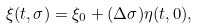<formula> <loc_0><loc_0><loc_500><loc_500>\xi ( t , \sigma ) = \xi _ { 0 } + ( \Delta \sigma ) \eta ( t , 0 ) ,</formula> 